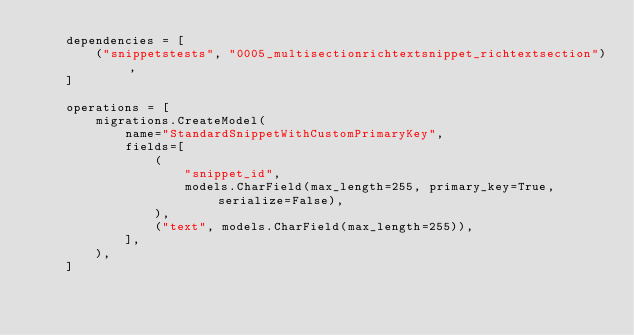Convert code to text. <code><loc_0><loc_0><loc_500><loc_500><_Python_>    dependencies = [
        ("snippetstests", "0005_multisectionrichtextsnippet_richtextsection"),
    ]

    operations = [
        migrations.CreateModel(
            name="StandardSnippetWithCustomPrimaryKey",
            fields=[
                (
                    "snippet_id",
                    models.CharField(max_length=255, primary_key=True, serialize=False),
                ),
                ("text", models.CharField(max_length=255)),
            ],
        ),
    ]
</code> 